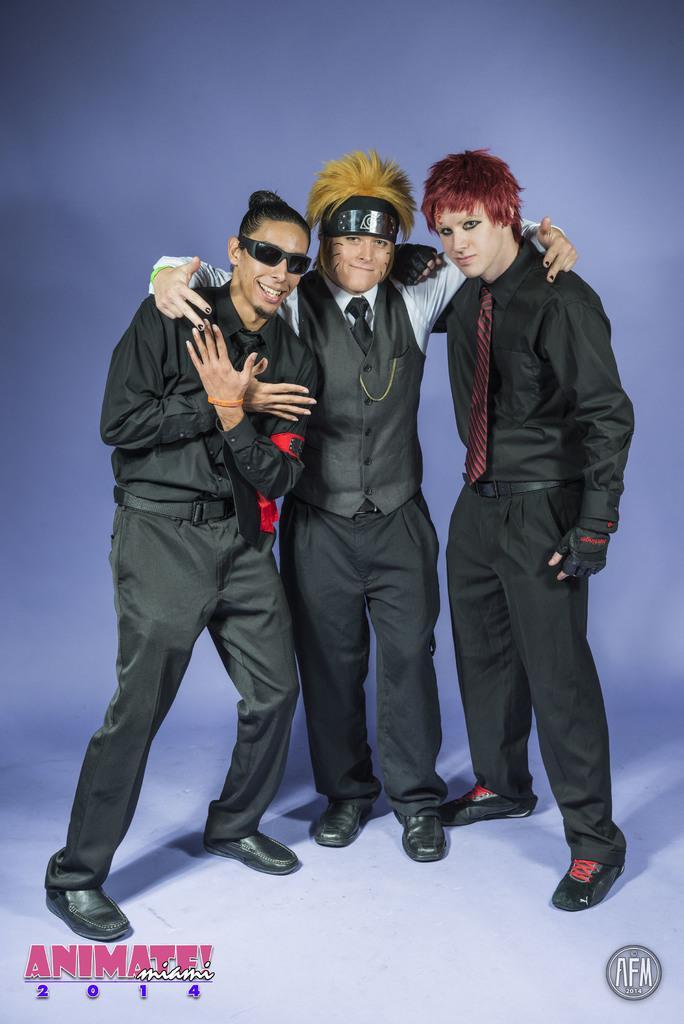In one or two sentences, can you explain what this image depicts? Background portion of the picture is blue in color. Here we can see people standing and giving a pose. At the bottom portion of the picture we can see water marks. 